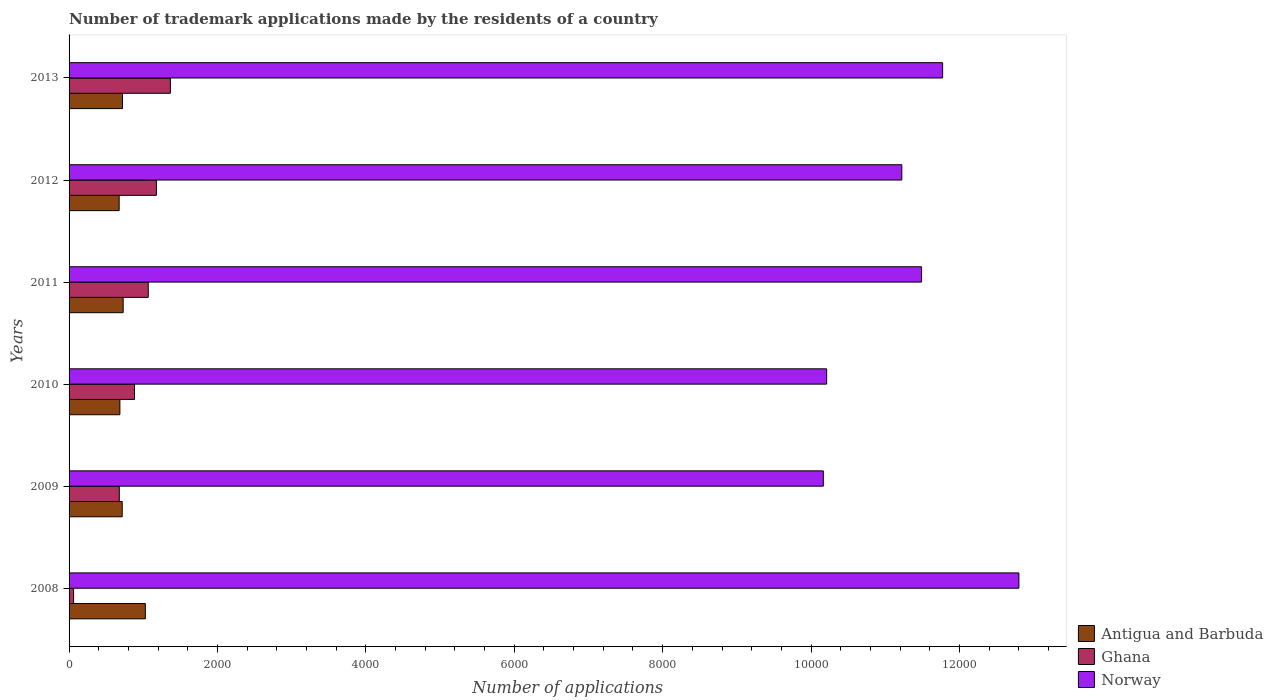How many groups of bars are there?
Your response must be concise. 6. Are the number of bars on each tick of the Y-axis equal?
Keep it short and to the point. Yes. How many bars are there on the 5th tick from the top?
Offer a very short reply. 3. How many bars are there on the 3rd tick from the bottom?
Your response must be concise. 3. What is the number of trademark applications made by the residents in Antigua and Barbuda in 2012?
Your answer should be very brief. 675. Across all years, what is the maximum number of trademark applications made by the residents in Ghana?
Your response must be concise. 1365. Across all years, what is the minimum number of trademark applications made by the residents in Norway?
Your answer should be very brief. 1.02e+04. In which year was the number of trademark applications made by the residents in Ghana maximum?
Offer a terse response. 2013. In which year was the number of trademark applications made by the residents in Norway minimum?
Offer a terse response. 2009. What is the total number of trademark applications made by the residents in Antigua and Barbuda in the graph?
Provide a short and direct response. 4553. What is the difference between the number of trademark applications made by the residents in Ghana in 2010 and that in 2011?
Your answer should be very brief. -185. What is the difference between the number of trademark applications made by the residents in Norway in 2010 and the number of trademark applications made by the residents in Antigua and Barbuda in 2013?
Make the answer very short. 9490. What is the average number of trademark applications made by the residents in Norway per year?
Offer a terse response. 1.13e+04. In the year 2011, what is the difference between the number of trademark applications made by the residents in Norway and number of trademark applications made by the residents in Ghana?
Provide a short and direct response. 1.04e+04. In how many years, is the number of trademark applications made by the residents in Ghana greater than 1200 ?
Provide a succinct answer. 1. What is the ratio of the number of trademark applications made by the residents in Antigua and Barbuda in 2008 to that in 2010?
Ensure brevity in your answer.  1.5. Is the number of trademark applications made by the residents in Norway in 2010 less than that in 2013?
Offer a very short reply. Yes. What is the difference between the highest and the second highest number of trademark applications made by the residents in Ghana?
Keep it short and to the point. 188. What is the difference between the highest and the lowest number of trademark applications made by the residents in Ghana?
Your answer should be very brief. 1304. Is the sum of the number of trademark applications made by the residents in Norway in 2008 and 2009 greater than the maximum number of trademark applications made by the residents in Ghana across all years?
Make the answer very short. Yes. What does the 2nd bar from the bottom in 2011 represents?
Give a very brief answer. Ghana. Is it the case that in every year, the sum of the number of trademark applications made by the residents in Ghana and number of trademark applications made by the residents in Antigua and Barbuda is greater than the number of trademark applications made by the residents in Norway?
Keep it short and to the point. No. How many bars are there?
Ensure brevity in your answer.  18. How many years are there in the graph?
Offer a very short reply. 6. What is the difference between two consecutive major ticks on the X-axis?
Provide a short and direct response. 2000. Does the graph contain any zero values?
Your answer should be compact. No. How are the legend labels stacked?
Your response must be concise. Vertical. What is the title of the graph?
Your answer should be very brief. Number of trademark applications made by the residents of a country. Does "Nigeria" appear as one of the legend labels in the graph?
Your answer should be very brief. No. What is the label or title of the X-axis?
Provide a succinct answer. Number of applications. What is the Number of applications in Antigua and Barbuda in 2008?
Your answer should be compact. 1028. What is the Number of applications of Ghana in 2008?
Provide a succinct answer. 61. What is the Number of applications in Norway in 2008?
Your answer should be very brief. 1.28e+04. What is the Number of applications in Antigua and Barbuda in 2009?
Ensure brevity in your answer.  716. What is the Number of applications of Ghana in 2009?
Your response must be concise. 677. What is the Number of applications of Norway in 2009?
Provide a succinct answer. 1.02e+04. What is the Number of applications of Antigua and Barbuda in 2010?
Make the answer very short. 685. What is the Number of applications of Ghana in 2010?
Provide a short and direct response. 882. What is the Number of applications in Norway in 2010?
Provide a succinct answer. 1.02e+04. What is the Number of applications of Antigua and Barbuda in 2011?
Offer a terse response. 729. What is the Number of applications in Ghana in 2011?
Provide a succinct answer. 1067. What is the Number of applications of Norway in 2011?
Provide a short and direct response. 1.15e+04. What is the Number of applications of Antigua and Barbuda in 2012?
Offer a very short reply. 675. What is the Number of applications of Ghana in 2012?
Provide a short and direct response. 1177. What is the Number of applications in Norway in 2012?
Make the answer very short. 1.12e+04. What is the Number of applications of Antigua and Barbuda in 2013?
Make the answer very short. 720. What is the Number of applications in Ghana in 2013?
Keep it short and to the point. 1365. What is the Number of applications in Norway in 2013?
Provide a succinct answer. 1.18e+04. Across all years, what is the maximum Number of applications in Antigua and Barbuda?
Provide a succinct answer. 1028. Across all years, what is the maximum Number of applications of Ghana?
Your answer should be very brief. 1365. Across all years, what is the maximum Number of applications of Norway?
Keep it short and to the point. 1.28e+04. Across all years, what is the minimum Number of applications of Antigua and Barbuda?
Ensure brevity in your answer.  675. Across all years, what is the minimum Number of applications in Norway?
Keep it short and to the point. 1.02e+04. What is the total Number of applications in Antigua and Barbuda in the graph?
Provide a short and direct response. 4553. What is the total Number of applications of Ghana in the graph?
Your answer should be compact. 5229. What is the total Number of applications of Norway in the graph?
Ensure brevity in your answer.  6.77e+04. What is the difference between the Number of applications of Antigua and Barbuda in 2008 and that in 2009?
Your answer should be very brief. 312. What is the difference between the Number of applications of Ghana in 2008 and that in 2009?
Your response must be concise. -616. What is the difference between the Number of applications in Norway in 2008 and that in 2009?
Provide a short and direct response. 2636. What is the difference between the Number of applications in Antigua and Barbuda in 2008 and that in 2010?
Make the answer very short. 343. What is the difference between the Number of applications in Ghana in 2008 and that in 2010?
Provide a short and direct response. -821. What is the difference between the Number of applications of Norway in 2008 and that in 2010?
Your response must be concise. 2591. What is the difference between the Number of applications of Antigua and Barbuda in 2008 and that in 2011?
Your response must be concise. 299. What is the difference between the Number of applications of Ghana in 2008 and that in 2011?
Keep it short and to the point. -1006. What is the difference between the Number of applications in Norway in 2008 and that in 2011?
Your answer should be compact. 1312. What is the difference between the Number of applications in Antigua and Barbuda in 2008 and that in 2012?
Your answer should be very brief. 353. What is the difference between the Number of applications in Ghana in 2008 and that in 2012?
Provide a succinct answer. -1116. What is the difference between the Number of applications in Norway in 2008 and that in 2012?
Offer a terse response. 1578. What is the difference between the Number of applications in Antigua and Barbuda in 2008 and that in 2013?
Keep it short and to the point. 308. What is the difference between the Number of applications in Ghana in 2008 and that in 2013?
Offer a terse response. -1304. What is the difference between the Number of applications of Norway in 2008 and that in 2013?
Your answer should be very brief. 1028. What is the difference between the Number of applications in Ghana in 2009 and that in 2010?
Your answer should be compact. -205. What is the difference between the Number of applications of Norway in 2009 and that in 2010?
Your response must be concise. -45. What is the difference between the Number of applications of Ghana in 2009 and that in 2011?
Your answer should be compact. -390. What is the difference between the Number of applications of Norway in 2009 and that in 2011?
Offer a very short reply. -1324. What is the difference between the Number of applications in Ghana in 2009 and that in 2012?
Provide a short and direct response. -500. What is the difference between the Number of applications of Norway in 2009 and that in 2012?
Keep it short and to the point. -1058. What is the difference between the Number of applications of Antigua and Barbuda in 2009 and that in 2013?
Provide a short and direct response. -4. What is the difference between the Number of applications of Ghana in 2009 and that in 2013?
Provide a succinct answer. -688. What is the difference between the Number of applications of Norway in 2009 and that in 2013?
Offer a terse response. -1608. What is the difference between the Number of applications in Antigua and Barbuda in 2010 and that in 2011?
Your response must be concise. -44. What is the difference between the Number of applications in Ghana in 2010 and that in 2011?
Keep it short and to the point. -185. What is the difference between the Number of applications in Norway in 2010 and that in 2011?
Ensure brevity in your answer.  -1279. What is the difference between the Number of applications in Ghana in 2010 and that in 2012?
Offer a terse response. -295. What is the difference between the Number of applications in Norway in 2010 and that in 2012?
Offer a terse response. -1013. What is the difference between the Number of applications of Antigua and Barbuda in 2010 and that in 2013?
Keep it short and to the point. -35. What is the difference between the Number of applications of Ghana in 2010 and that in 2013?
Offer a very short reply. -483. What is the difference between the Number of applications of Norway in 2010 and that in 2013?
Your answer should be compact. -1563. What is the difference between the Number of applications of Ghana in 2011 and that in 2012?
Provide a succinct answer. -110. What is the difference between the Number of applications of Norway in 2011 and that in 2012?
Provide a succinct answer. 266. What is the difference between the Number of applications in Antigua and Barbuda in 2011 and that in 2013?
Ensure brevity in your answer.  9. What is the difference between the Number of applications of Ghana in 2011 and that in 2013?
Offer a very short reply. -298. What is the difference between the Number of applications in Norway in 2011 and that in 2013?
Provide a succinct answer. -284. What is the difference between the Number of applications in Antigua and Barbuda in 2012 and that in 2013?
Give a very brief answer. -45. What is the difference between the Number of applications in Ghana in 2012 and that in 2013?
Keep it short and to the point. -188. What is the difference between the Number of applications in Norway in 2012 and that in 2013?
Provide a succinct answer. -550. What is the difference between the Number of applications of Antigua and Barbuda in 2008 and the Number of applications of Ghana in 2009?
Ensure brevity in your answer.  351. What is the difference between the Number of applications of Antigua and Barbuda in 2008 and the Number of applications of Norway in 2009?
Offer a very short reply. -9137. What is the difference between the Number of applications of Ghana in 2008 and the Number of applications of Norway in 2009?
Offer a terse response. -1.01e+04. What is the difference between the Number of applications in Antigua and Barbuda in 2008 and the Number of applications in Ghana in 2010?
Give a very brief answer. 146. What is the difference between the Number of applications of Antigua and Barbuda in 2008 and the Number of applications of Norway in 2010?
Make the answer very short. -9182. What is the difference between the Number of applications of Ghana in 2008 and the Number of applications of Norway in 2010?
Your answer should be compact. -1.01e+04. What is the difference between the Number of applications of Antigua and Barbuda in 2008 and the Number of applications of Ghana in 2011?
Ensure brevity in your answer.  -39. What is the difference between the Number of applications in Antigua and Barbuda in 2008 and the Number of applications in Norway in 2011?
Offer a terse response. -1.05e+04. What is the difference between the Number of applications of Ghana in 2008 and the Number of applications of Norway in 2011?
Ensure brevity in your answer.  -1.14e+04. What is the difference between the Number of applications of Antigua and Barbuda in 2008 and the Number of applications of Ghana in 2012?
Your answer should be very brief. -149. What is the difference between the Number of applications in Antigua and Barbuda in 2008 and the Number of applications in Norway in 2012?
Ensure brevity in your answer.  -1.02e+04. What is the difference between the Number of applications of Ghana in 2008 and the Number of applications of Norway in 2012?
Your response must be concise. -1.12e+04. What is the difference between the Number of applications in Antigua and Barbuda in 2008 and the Number of applications in Ghana in 2013?
Provide a succinct answer. -337. What is the difference between the Number of applications in Antigua and Barbuda in 2008 and the Number of applications in Norway in 2013?
Your response must be concise. -1.07e+04. What is the difference between the Number of applications in Ghana in 2008 and the Number of applications in Norway in 2013?
Ensure brevity in your answer.  -1.17e+04. What is the difference between the Number of applications in Antigua and Barbuda in 2009 and the Number of applications in Ghana in 2010?
Your response must be concise. -166. What is the difference between the Number of applications in Antigua and Barbuda in 2009 and the Number of applications in Norway in 2010?
Your answer should be very brief. -9494. What is the difference between the Number of applications in Ghana in 2009 and the Number of applications in Norway in 2010?
Ensure brevity in your answer.  -9533. What is the difference between the Number of applications in Antigua and Barbuda in 2009 and the Number of applications in Ghana in 2011?
Your answer should be compact. -351. What is the difference between the Number of applications of Antigua and Barbuda in 2009 and the Number of applications of Norway in 2011?
Give a very brief answer. -1.08e+04. What is the difference between the Number of applications in Ghana in 2009 and the Number of applications in Norway in 2011?
Your answer should be compact. -1.08e+04. What is the difference between the Number of applications in Antigua and Barbuda in 2009 and the Number of applications in Ghana in 2012?
Offer a very short reply. -461. What is the difference between the Number of applications in Antigua and Barbuda in 2009 and the Number of applications in Norway in 2012?
Keep it short and to the point. -1.05e+04. What is the difference between the Number of applications in Ghana in 2009 and the Number of applications in Norway in 2012?
Ensure brevity in your answer.  -1.05e+04. What is the difference between the Number of applications of Antigua and Barbuda in 2009 and the Number of applications of Ghana in 2013?
Offer a terse response. -649. What is the difference between the Number of applications in Antigua and Barbuda in 2009 and the Number of applications in Norway in 2013?
Keep it short and to the point. -1.11e+04. What is the difference between the Number of applications in Ghana in 2009 and the Number of applications in Norway in 2013?
Offer a terse response. -1.11e+04. What is the difference between the Number of applications in Antigua and Barbuda in 2010 and the Number of applications in Ghana in 2011?
Offer a terse response. -382. What is the difference between the Number of applications in Antigua and Barbuda in 2010 and the Number of applications in Norway in 2011?
Provide a short and direct response. -1.08e+04. What is the difference between the Number of applications in Ghana in 2010 and the Number of applications in Norway in 2011?
Keep it short and to the point. -1.06e+04. What is the difference between the Number of applications of Antigua and Barbuda in 2010 and the Number of applications of Ghana in 2012?
Offer a terse response. -492. What is the difference between the Number of applications of Antigua and Barbuda in 2010 and the Number of applications of Norway in 2012?
Offer a terse response. -1.05e+04. What is the difference between the Number of applications of Ghana in 2010 and the Number of applications of Norway in 2012?
Offer a terse response. -1.03e+04. What is the difference between the Number of applications in Antigua and Barbuda in 2010 and the Number of applications in Ghana in 2013?
Provide a succinct answer. -680. What is the difference between the Number of applications in Antigua and Barbuda in 2010 and the Number of applications in Norway in 2013?
Provide a succinct answer. -1.11e+04. What is the difference between the Number of applications of Ghana in 2010 and the Number of applications of Norway in 2013?
Your response must be concise. -1.09e+04. What is the difference between the Number of applications of Antigua and Barbuda in 2011 and the Number of applications of Ghana in 2012?
Give a very brief answer. -448. What is the difference between the Number of applications of Antigua and Barbuda in 2011 and the Number of applications of Norway in 2012?
Offer a very short reply. -1.05e+04. What is the difference between the Number of applications of Ghana in 2011 and the Number of applications of Norway in 2012?
Give a very brief answer. -1.02e+04. What is the difference between the Number of applications of Antigua and Barbuda in 2011 and the Number of applications of Ghana in 2013?
Make the answer very short. -636. What is the difference between the Number of applications in Antigua and Barbuda in 2011 and the Number of applications in Norway in 2013?
Make the answer very short. -1.10e+04. What is the difference between the Number of applications of Ghana in 2011 and the Number of applications of Norway in 2013?
Ensure brevity in your answer.  -1.07e+04. What is the difference between the Number of applications in Antigua and Barbuda in 2012 and the Number of applications in Ghana in 2013?
Your answer should be very brief. -690. What is the difference between the Number of applications of Antigua and Barbuda in 2012 and the Number of applications of Norway in 2013?
Make the answer very short. -1.11e+04. What is the difference between the Number of applications of Ghana in 2012 and the Number of applications of Norway in 2013?
Your response must be concise. -1.06e+04. What is the average Number of applications of Antigua and Barbuda per year?
Your answer should be compact. 758.83. What is the average Number of applications in Ghana per year?
Provide a short and direct response. 871.5. What is the average Number of applications of Norway per year?
Your answer should be very brief. 1.13e+04. In the year 2008, what is the difference between the Number of applications in Antigua and Barbuda and Number of applications in Ghana?
Keep it short and to the point. 967. In the year 2008, what is the difference between the Number of applications of Antigua and Barbuda and Number of applications of Norway?
Ensure brevity in your answer.  -1.18e+04. In the year 2008, what is the difference between the Number of applications of Ghana and Number of applications of Norway?
Make the answer very short. -1.27e+04. In the year 2009, what is the difference between the Number of applications of Antigua and Barbuda and Number of applications of Norway?
Provide a succinct answer. -9449. In the year 2009, what is the difference between the Number of applications of Ghana and Number of applications of Norway?
Provide a short and direct response. -9488. In the year 2010, what is the difference between the Number of applications of Antigua and Barbuda and Number of applications of Ghana?
Provide a short and direct response. -197. In the year 2010, what is the difference between the Number of applications of Antigua and Barbuda and Number of applications of Norway?
Make the answer very short. -9525. In the year 2010, what is the difference between the Number of applications in Ghana and Number of applications in Norway?
Your answer should be very brief. -9328. In the year 2011, what is the difference between the Number of applications in Antigua and Barbuda and Number of applications in Ghana?
Your answer should be very brief. -338. In the year 2011, what is the difference between the Number of applications in Antigua and Barbuda and Number of applications in Norway?
Offer a very short reply. -1.08e+04. In the year 2011, what is the difference between the Number of applications of Ghana and Number of applications of Norway?
Your answer should be compact. -1.04e+04. In the year 2012, what is the difference between the Number of applications in Antigua and Barbuda and Number of applications in Ghana?
Your response must be concise. -502. In the year 2012, what is the difference between the Number of applications of Antigua and Barbuda and Number of applications of Norway?
Your answer should be very brief. -1.05e+04. In the year 2012, what is the difference between the Number of applications in Ghana and Number of applications in Norway?
Provide a short and direct response. -1.00e+04. In the year 2013, what is the difference between the Number of applications in Antigua and Barbuda and Number of applications in Ghana?
Provide a short and direct response. -645. In the year 2013, what is the difference between the Number of applications of Antigua and Barbuda and Number of applications of Norway?
Offer a very short reply. -1.11e+04. In the year 2013, what is the difference between the Number of applications of Ghana and Number of applications of Norway?
Offer a terse response. -1.04e+04. What is the ratio of the Number of applications in Antigua and Barbuda in 2008 to that in 2009?
Ensure brevity in your answer.  1.44. What is the ratio of the Number of applications in Ghana in 2008 to that in 2009?
Make the answer very short. 0.09. What is the ratio of the Number of applications of Norway in 2008 to that in 2009?
Keep it short and to the point. 1.26. What is the ratio of the Number of applications of Antigua and Barbuda in 2008 to that in 2010?
Offer a very short reply. 1.5. What is the ratio of the Number of applications in Ghana in 2008 to that in 2010?
Provide a short and direct response. 0.07. What is the ratio of the Number of applications of Norway in 2008 to that in 2010?
Keep it short and to the point. 1.25. What is the ratio of the Number of applications of Antigua and Barbuda in 2008 to that in 2011?
Your response must be concise. 1.41. What is the ratio of the Number of applications in Ghana in 2008 to that in 2011?
Offer a very short reply. 0.06. What is the ratio of the Number of applications of Norway in 2008 to that in 2011?
Your answer should be very brief. 1.11. What is the ratio of the Number of applications in Antigua and Barbuda in 2008 to that in 2012?
Keep it short and to the point. 1.52. What is the ratio of the Number of applications in Ghana in 2008 to that in 2012?
Ensure brevity in your answer.  0.05. What is the ratio of the Number of applications of Norway in 2008 to that in 2012?
Your response must be concise. 1.14. What is the ratio of the Number of applications of Antigua and Barbuda in 2008 to that in 2013?
Give a very brief answer. 1.43. What is the ratio of the Number of applications of Ghana in 2008 to that in 2013?
Your response must be concise. 0.04. What is the ratio of the Number of applications in Norway in 2008 to that in 2013?
Provide a succinct answer. 1.09. What is the ratio of the Number of applications of Antigua and Barbuda in 2009 to that in 2010?
Ensure brevity in your answer.  1.05. What is the ratio of the Number of applications of Ghana in 2009 to that in 2010?
Ensure brevity in your answer.  0.77. What is the ratio of the Number of applications in Norway in 2009 to that in 2010?
Give a very brief answer. 1. What is the ratio of the Number of applications of Antigua and Barbuda in 2009 to that in 2011?
Your response must be concise. 0.98. What is the ratio of the Number of applications of Ghana in 2009 to that in 2011?
Provide a succinct answer. 0.63. What is the ratio of the Number of applications of Norway in 2009 to that in 2011?
Provide a succinct answer. 0.88. What is the ratio of the Number of applications of Antigua and Barbuda in 2009 to that in 2012?
Offer a very short reply. 1.06. What is the ratio of the Number of applications of Ghana in 2009 to that in 2012?
Your answer should be compact. 0.58. What is the ratio of the Number of applications in Norway in 2009 to that in 2012?
Provide a succinct answer. 0.91. What is the ratio of the Number of applications of Ghana in 2009 to that in 2013?
Keep it short and to the point. 0.5. What is the ratio of the Number of applications of Norway in 2009 to that in 2013?
Your response must be concise. 0.86. What is the ratio of the Number of applications in Antigua and Barbuda in 2010 to that in 2011?
Make the answer very short. 0.94. What is the ratio of the Number of applications of Ghana in 2010 to that in 2011?
Keep it short and to the point. 0.83. What is the ratio of the Number of applications in Norway in 2010 to that in 2011?
Your response must be concise. 0.89. What is the ratio of the Number of applications in Antigua and Barbuda in 2010 to that in 2012?
Offer a terse response. 1.01. What is the ratio of the Number of applications of Ghana in 2010 to that in 2012?
Offer a very short reply. 0.75. What is the ratio of the Number of applications of Norway in 2010 to that in 2012?
Keep it short and to the point. 0.91. What is the ratio of the Number of applications in Antigua and Barbuda in 2010 to that in 2013?
Offer a very short reply. 0.95. What is the ratio of the Number of applications in Ghana in 2010 to that in 2013?
Provide a succinct answer. 0.65. What is the ratio of the Number of applications of Norway in 2010 to that in 2013?
Provide a short and direct response. 0.87. What is the ratio of the Number of applications of Ghana in 2011 to that in 2012?
Offer a terse response. 0.91. What is the ratio of the Number of applications in Norway in 2011 to that in 2012?
Keep it short and to the point. 1.02. What is the ratio of the Number of applications in Antigua and Barbuda in 2011 to that in 2013?
Your answer should be compact. 1.01. What is the ratio of the Number of applications of Ghana in 2011 to that in 2013?
Your response must be concise. 0.78. What is the ratio of the Number of applications of Norway in 2011 to that in 2013?
Your response must be concise. 0.98. What is the ratio of the Number of applications in Antigua and Barbuda in 2012 to that in 2013?
Offer a very short reply. 0.94. What is the ratio of the Number of applications of Ghana in 2012 to that in 2013?
Your answer should be very brief. 0.86. What is the ratio of the Number of applications in Norway in 2012 to that in 2013?
Give a very brief answer. 0.95. What is the difference between the highest and the second highest Number of applications of Antigua and Barbuda?
Offer a very short reply. 299. What is the difference between the highest and the second highest Number of applications in Ghana?
Give a very brief answer. 188. What is the difference between the highest and the second highest Number of applications of Norway?
Provide a short and direct response. 1028. What is the difference between the highest and the lowest Number of applications in Antigua and Barbuda?
Keep it short and to the point. 353. What is the difference between the highest and the lowest Number of applications of Ghana?
Your answer should be very brief. 1304. What is the difference between the highest and the lowest Number of applications of Norway?
Provide a succinct answer. 2636. 